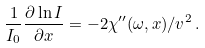Convert formula to latex. <formula><loc_0><loc_0><loc_500><loc_500>\frac { 1 } { I _ { 0 } } \frac { \partial \ln I } { \partial x } = - 2 \chi ^ { \prime \prime } ( \omega , x ) / v ^ { 2 } \, .</formula> 